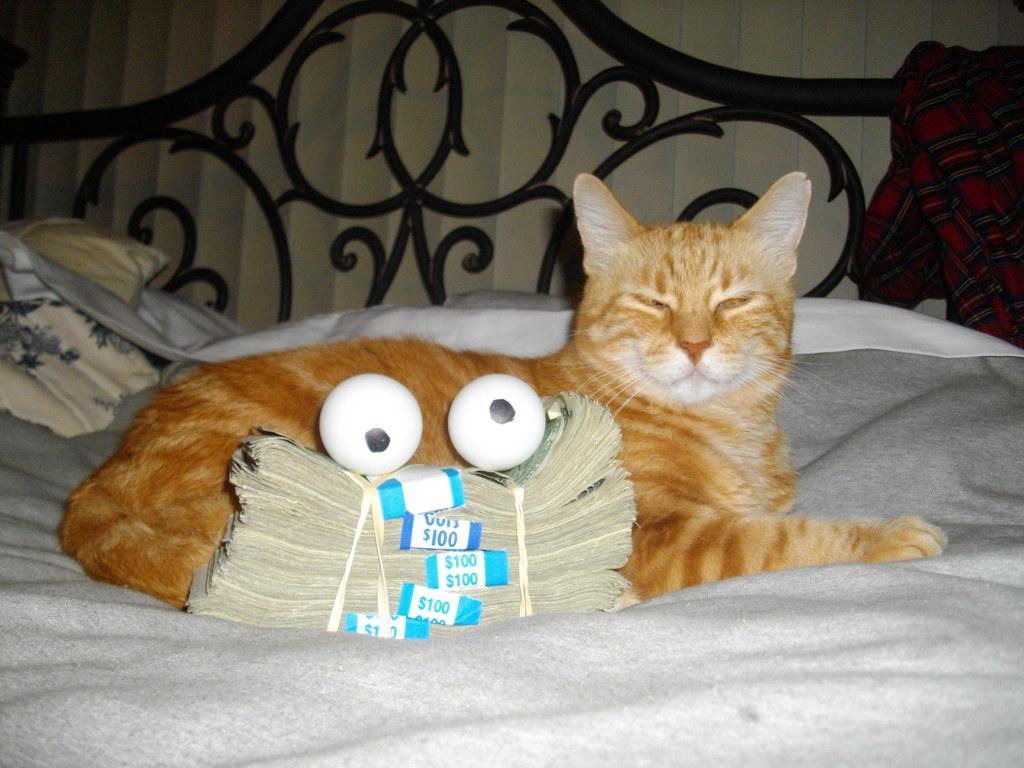What animal is present in the picture? There is a cat in the picture. Where is the cat located? The cat is on a bed. What else can be seen in the picture besides the cat? There are bugs and two eggs on the bugs in the picture. What is covering the bed? There is cloth visible on the bed. What type of knowledge can be gained from the oven in the picture? There is no oven present in the picture, so no knowledge can be gained from it. 